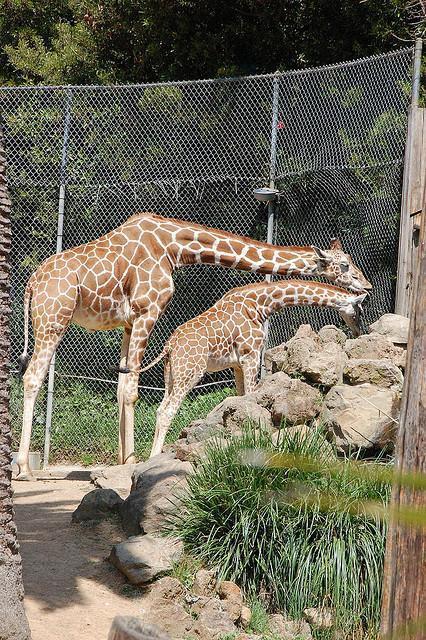How many giraffes are in the picture?
Give a very brief answer. 2. How many cats are facing away?
Give a very brief answer. 0. 